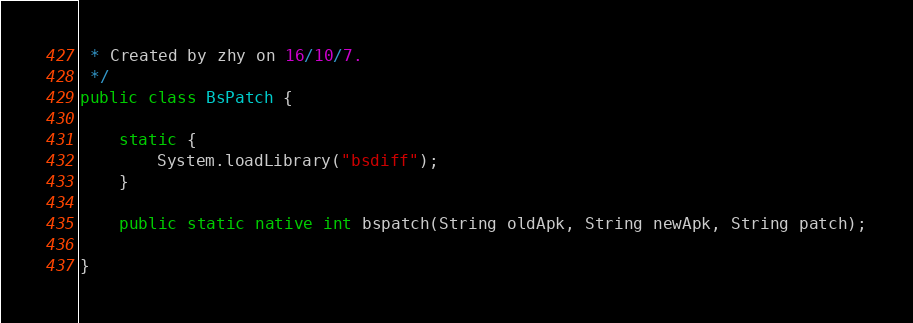<code> <loc_0><loc_0><loc_500><loc_500><_Java_> * Created by zhy on 16/10/7.
 */
public class BsPatch {

    static {
        System.loadLibrary("bsdiff");
    }

    public static native int bspatch(String oldApk, String newApk, String patch);

}
</code> 